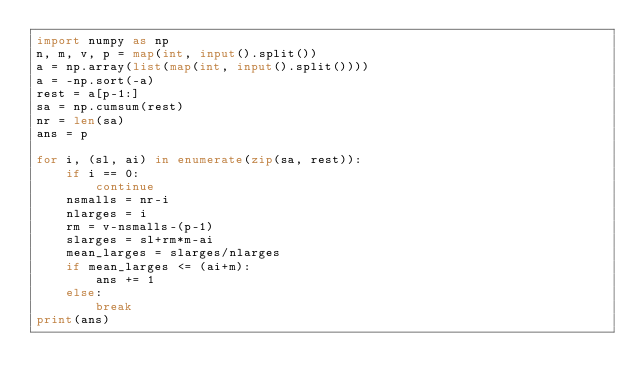Convert code to text. <code><loc_0><loc_0><loc_500><loc_500><_Python_>import numpy as np
n, m, v, p = map(int, input().split())
a = np.array(list(map(int, input().split())))
a = -np.sort(-a)
rest = a[p-1:]
sa = np.cumsum(rest)
nr = len(sa)
ans = p

for i, (sl, ai) in enumerate(zip(sa, rest)):
    if i == 0:
        continue
    nsmalls = nr-i
    nlarges = i
    rm = v-nsmalls-(p-1)
    slarges = sl+rm*m-ai
    mean_larges = slarges/nlarges
    if mean_larges <= (ai+m):
        ans += 1
    else:
        break
print(ans)
</code> 